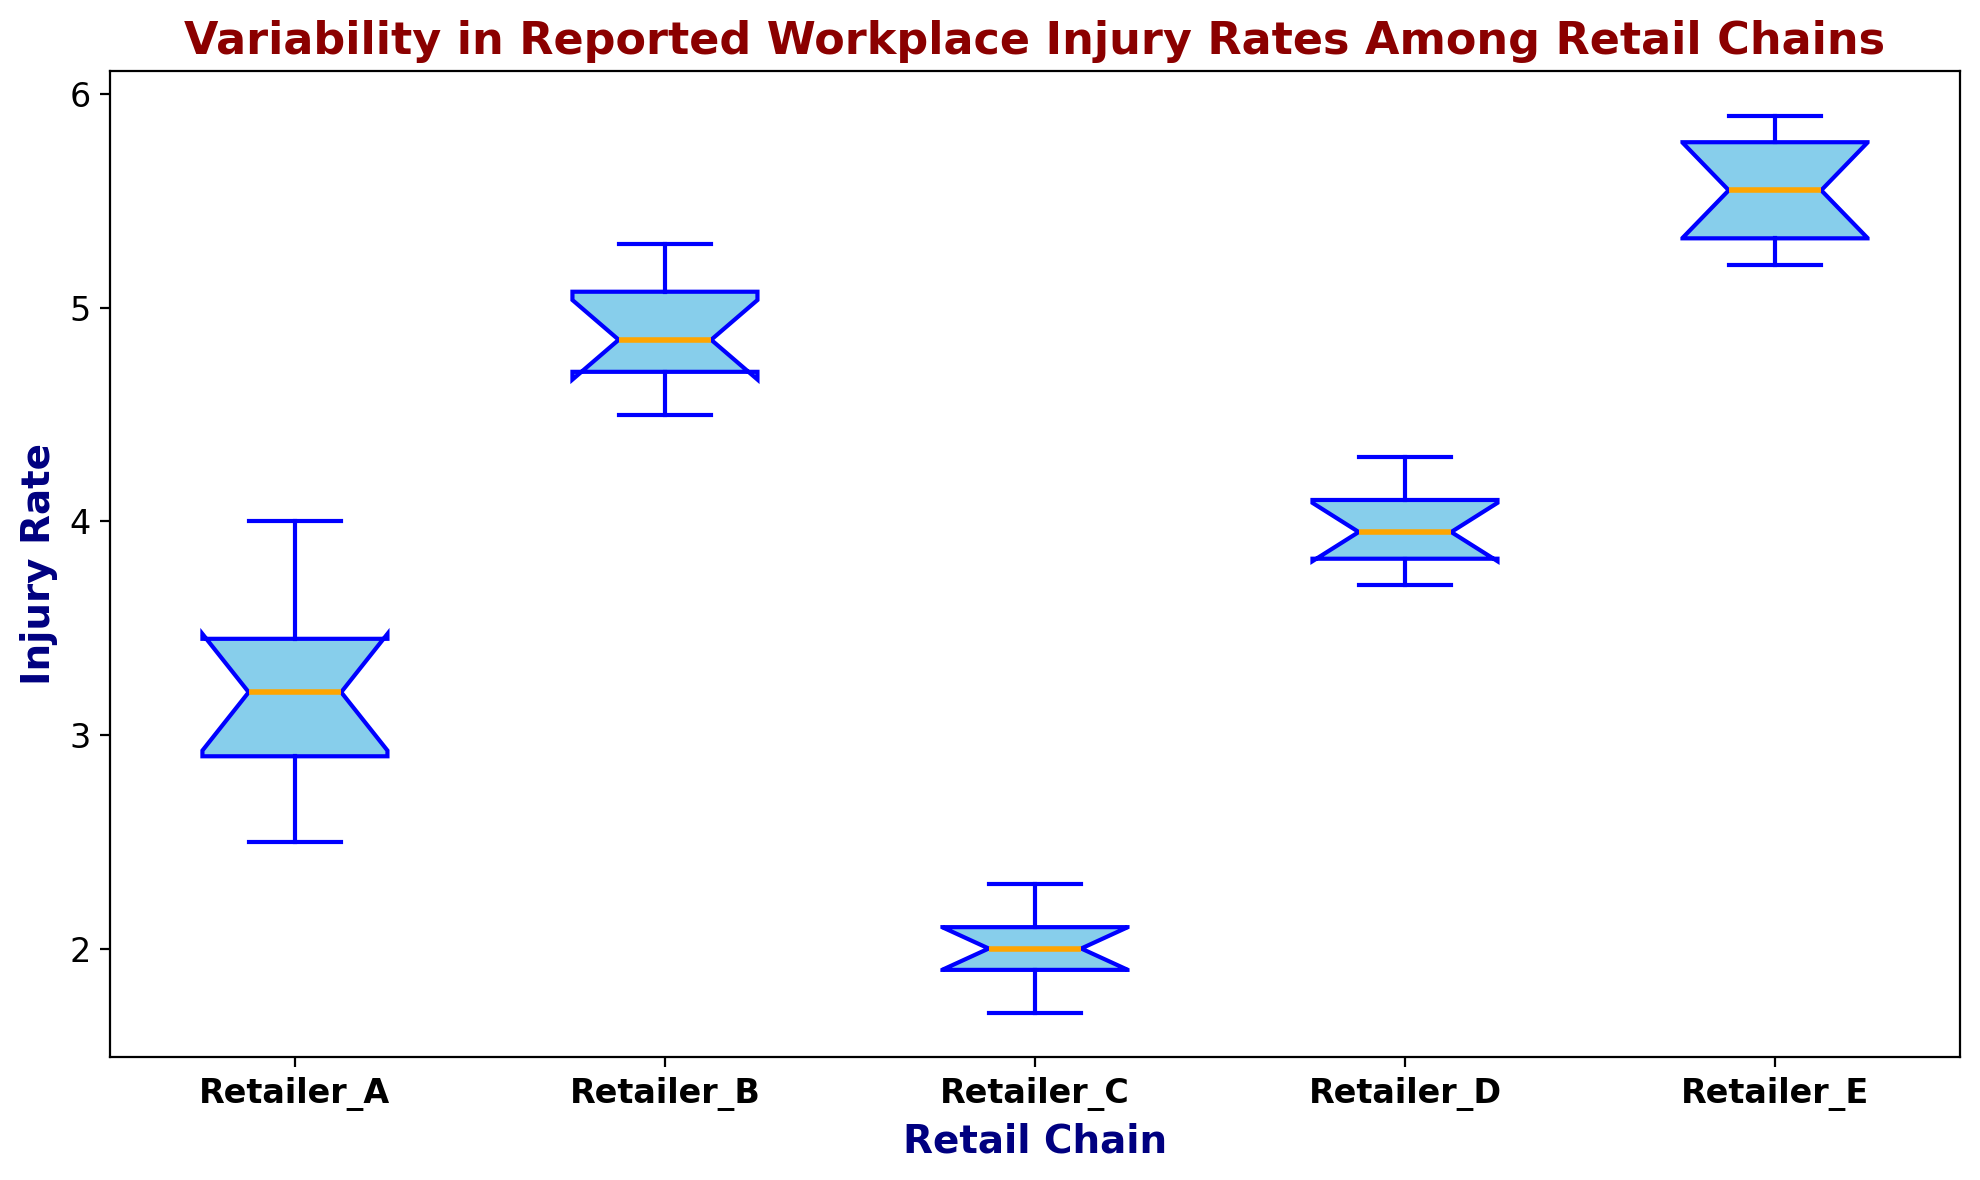Which retail chain has the highest median injury rate? Identify the median value for each retail chain's box plot. The one with the highest median is the answer.
Answer: Retailer_E Which retail chain exhibits the greatest variability in injury rates? Variability is depicted by the height of the box (interquartile range) and the whiskers in the box plot. Identify the chain with the tallest box and longest whiskers.
Answer: Retailer_B How does the median injury rate of Retailer_A compare to Retailer_C? Compare the median lines in the box plots of Retailer_A and Retailer_C.
Answer: Retailer_A's median is higher than Retailer_C's Which retail chain has outliers, and how are they visually represented? Look for points outside the whiskers, typically marked as individual dots.
Answer: No outliers What are the ranges between the first and third quartiles for Retailer_D and Retailer_E? Locate the boxes' top and bottom edges (first and third quartiles) for Retailer_D and Retailer_E. Subtract the lower quartile from the upper quartile for each.
Answer: Retailer_D: 4.1 - 3.8 = 0.3, Retailer_E: 5.8 - 5.3 = 0.5 Which retail chain has the lowest minimum injury rate? Identify the lowest point of the whiskers for each retail chain. The one with the lowest value is the answer.
Answer: Retailer_C Are there any retail chains with the same median injury rate, and if so, which ones? Check if any box plots have their median lines at the same level.
Answer: None What is the difference between the highest injury rate and lowest injury rate for Retailer_E? Identify the top of the highest whisker and the bottom of the lowest whisker for Retailer_E box plot. Subtract the lowest value from the highest value.
Answer: 5.9 - 5.2 = 0.7 Compare the interquartile range of Retailer_B and Retailer_C. Which is larger? Calculate the interquartile range (IQR) for both Retailer_B (third quartile - first quartile) and Retailer_C. Compare the values.
Answer: Retailer_B's IQR is larger If you were to rank the retail chains by their median injury rates, from highest to lowest, what would be the ranking order? Identify and list the median values from highest to lowest for each retail chain.
Answer: Retailer_E, Retailer_B, Retailer_D, Retailer_A, Retailer_C 